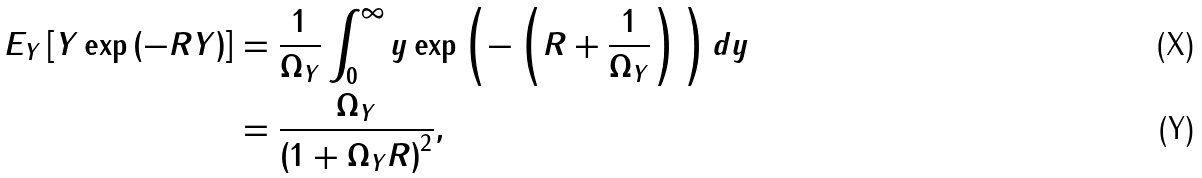Convert formula to latex. <formula><loc_0><loc_0><loc_500><loc_500>E _ { Y } \left [ Y \exp \left ( { - R Y } \right ) \right ] & = \frac { 1 } { \Omega _ { Y } } \int _ { 0 } ^ { \infty } y \exp \left ( { - \left ( R + \frac { 1 } { \Omega _ { Y } } \right ) } \, \right ) d y \\ & = \frac { \Omega _ { Y } } { \left ( 1 + \Omega _ { Y } R \right ) ^ { 2 } } ,</formula> 